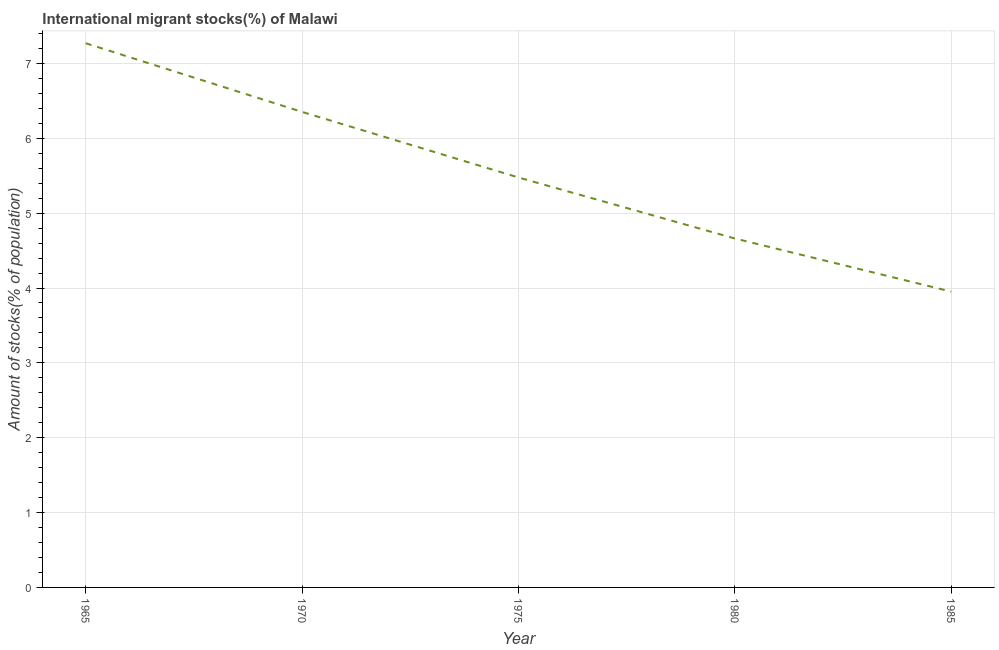What is the number of international migrant stocks in 1985?
Your response must be concise. 3.95. Across all years, what is the maximum number of international migrant stocks?
Your response must be concise. 7.27. Across all years, what is the minimum number of international migrant stocks?
Your response must be concise. 3.95. In which year was the number of international migrant stocks maximum?
Keep it short and to the point. 1965. What is the sum of the number of international migrant stocks?
Offer a terse response. 27.71. What is the difference between the number of international migrant stocks in 1965 and 1970?
Provide a succinct answer. 0.92. What is the average number of international migrant stocks per year?
Give a very brief answer. 5.54. What is the median number of international migrant stocks?
Your answer should be compact. 5.48. In how many years, is the number of international migrant stocks greater than 6.6 %?
Ensure brevity in your answer.  1. Do a majority of the years between 1980 and 1985 (inclusive) have number of international migrant stocks greater than 6.8 %?
Keep it short and to the point. No. What is the ratio of the number of international migrant stocks in 1975 to that in 1985?
Offer a very short reply. 1.39. Is the difference between the number of international migrant stocks in 1970 and 1975 greater than the difference between any two years?
Your answer should be compact. No. What is the difference between the highest and the second highest number of international migrant stocks?
Provide a succinct answer. 0.92. What is the difference between the highest and the lowest number of international migrant stocks?
Provide a short and direct response. 3.32. In how many years, is the number of international migrant stocks greater than the average number of international migrant stocks taken over all years?
Make the answer very short. 2. How many lines are there?
Offer a very short reply. 1. What is the difference between two consecutive major ticks on the Y-axis?
Your response must be concise. 1. Are the values on the major ticks of Y-axis written in scientific E-notation?
Your answer should be compact. No. Does the graph contain grids?
Ensure brevity in your answer.  Yes. What is the title of the graph?
Make the answer very short. International migrant stocks(%) of Malawi. What is the label or title of the X-axis?
Your response must be concise. Year. What is the label or title of the Y-axis?
Your answer should be compact. Amount of stocks(% of population). What is the Amount of stocks(% of population) in 1965?
Keep it short and to the point. 7.27. What is the Amount of stocks(% of population) in 1970?
Your answer should be very brief. 6.35. What is the Amount of stocks(% of population) of 1975?
Make the answer very short. 5.48. What is the Amount of stocks(% of population) in 1980?
Your response must be concise. 4.66. What is the Amount of stocks(% of population) of 1985?
Your answer should be very brief. 3.95. What is the difference between the Amount of stocks(% of population) in 1965 and 1970?
Ensure brevity in your answer.  0.92. What is the difference between the Amount of stocks(% of population) in 1965 and 1975?
Offer a very short reply. 1.79. What is the difference between the Amount of stocks(% of population) in 1965 and 1980?
Keep it short and to the point. 2.61. What is the difference between the Amount of stocks(% of population) in 1965 and 1985?
Your answer should be very brief. 3.32. What is the difference between the Amount of stocks(% of population) in 1970 and 1975?
Your answer should be very brief. 0.88. What is the difference between the Amount of stocks(% of population) in 1970 and 1980?
Offer a terse response. 1.69. What is the difference between the Amount of stocks(% of population) in 1970 and 1985?
Your answer should be compact. 2.4. What is the difference between the Amount of stocks(% of population) in 1975 and 1980?
Your answer should be very brief. 0.82. What is the difference between the Amount of stocks(% of population) in 1975 and 1985?
Your answer should be compact. 1.52. What is the difference between the Amount of stocks(% of population) in 1980 and 1985?
Your response must be concise. 0.71. What is the ratio of the Amount of stocks(% of population) in 1965 to that in 1970?
Your answer should be very brief. 1.14. What is the ratio of the Amount of stocks(% of population) in 1965 to that in 1975?
Your response must be concise. 1.33. What is the ratio of the Amount of stocks(% of population) in 1965 to that in 1980?
Ensure brevity in your answer.  1.56. What is the ratio of the Amount of stocks(% of population) in 1965 to that in 1985?
Give a very brief answer. 1.84. What is the ratio of the Amount of stocks(% of population) in 1970 to that in 1975?
Give a very brief answer. 1.16. What is the ratio of the Amount of stocks(% of population) in 1970 to that in 1980?
Give a very brief answer. 1.36. What is the ratio of the Amount of stocks(% of population) in 1970 to that in 1985?
Ensure brevity in your answer.  1.61. What is the ratio of the Amount of stocks(% of population) in 1975 to that in 1980?
Make the answer very short. 1.18. What is the ratio of the Amount of stocks(% of population) in 1975 to that in 1985?
Ensure brevity in your answer.  1.39. What is the ratio of the Amount of stocks(% of population) in 1980 to that in 1985?
Your answer should be compact. 1.18. 